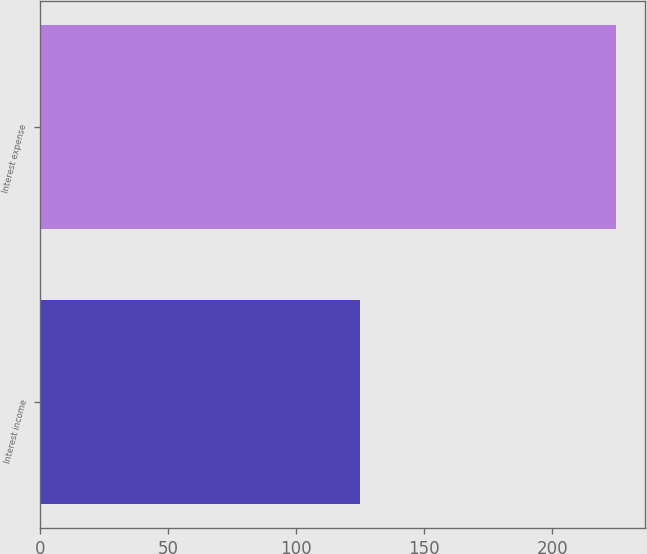Convert chart to OTSL. <chart><loc_0><loc_0><loc_500><loc_500><bar_chart><fcel>Interest income<fcel>Interest expense<nl><fcel>125<fcel>225<nl></chart> 